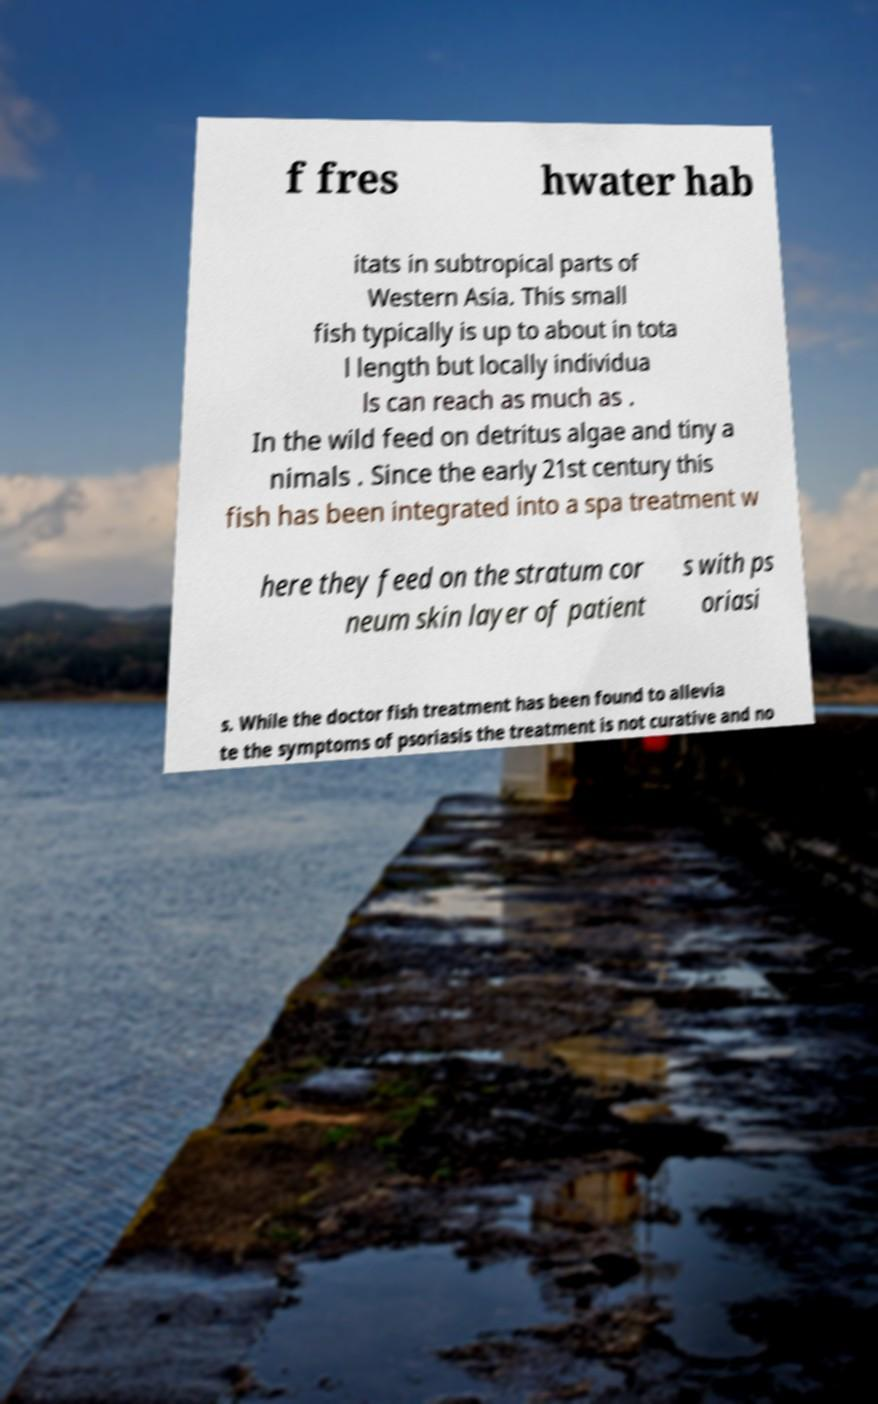Could you extract and type out the text from this image? f fres hwater hab itats in subtropical parts of Western Asia. This small fish typically is up to about in tota l length but locally individua ls can reach as much as . In the wild feed on detritus algae and tiny a nimals . Since the early 21st century this fish has been integrated into a spa treatment w here they feed on the stratum cor neum skin layer of patient s with ps oriasi s. While the doctor fish treatment has been found to allevia te the symptoms of psoriasis the treatment is not curative and no 